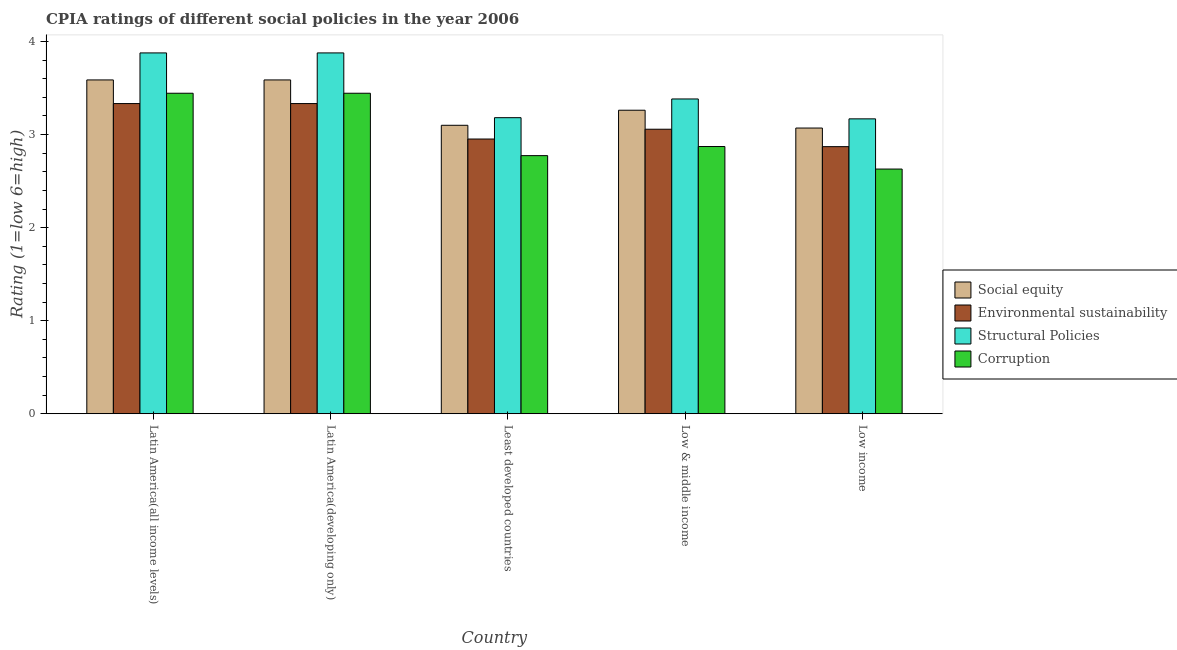How many different coloured bars are there?
Provide a succinct answer. 4. Are the number of bars on each tick of the X-axis equal?
Ensure brevity in your answer.  Yes. How many bars are there on the 1st tick from the left?
Make the answer very short. 4. What is the label of the 1st group of bars from the left?
Keep it short and to the point. Latin America(all income levels). What is the cpia rating of structural policies in Latin America(developing only)?
Your response must be concise. 3.88. Across all countries, what is the maximum cpia rating of corruption?
Make the answer very short. 3.44. Across all countries, what is the minimum cpia rating of social equity?
Provide a succinct answer. 3.07. In which country was the cpia rating of structural policies maximum?
Ensure brevity in your answer.  Latin America(all income levels). What is the total cpia rating of social equity in the graph?
Keep it short and to the point. 16.61. What is the difference between the cpia rating of social equity in Latin America(all income levels) and that in Least developed countries?
Provide a short and direct response. 0.49. What is the difference between the cpia rating of environmental sustainability in Latin America(developing only) and the cpia rating of social equity in Low & middle income?
Your answer should be compact. 0.07. What is the average cpia rating of social equity per country?
Make the answer very short. 3.32. What is the difference between the cpia rating of environmental sustainability and cpia rating of social equity in Least developed countries?
Provide a short and direct response. -0.15. In how many countries, is the cpia rating of structural policies greater than 1.2 ?
Provide a short and direct response. 5. What is the ratio of the cpia rating of corruption in Latin America(all income levels) to that in Least developed countries?
Offer a very short reply. 1.24. What is the difference between the highest and the second highest cpia rating of structural policies?
Your answer should be compact. 0. What is the difference between the highest and the lowest cpia rating of corruption?
Ensure brevity in your answer.  0.81. In how many countries, is the cpia rating of environmental sustainability greater than the average cpia rating of environmental sustainability taken over all countries?
Your response must be concise. 2. What does the 3rd bar from the left in Low income represents?
Keep it short and to the point. Structural Policies. What does the 3rd bar from the right in Latin America(developing only) represents?
Your answer should be compact. Environmental sustainability. How many bars are there?
Ensure brevity in your answer.  20. Are all the bars in the graph horizontal?
Ensure brevity in your answer.  No. What is the difference between two consecutive major ticks on the Y-axis?
Provide a short and direct response. 1. Are the values on the major ticks of Y-axis written in scientific E-notation?
Ensure brevity in your answer.  No. Does the graph contain any zero values?
Make the answer very short. No. Does the graph contain grids?
Offer a very short reply. No. How are the legend labels stacked?
Keep it short and to the point. Vertical. What is the title of the graph?
Your response must be concise. CPIA ratings of different social policies in the year 2006. What is the Rating (1=low 6=high) in Social equity in Latin America(all income levels)?
Provide a succinct answer. 3.59. What is the Rating (1=low 6=high) of Environmental sustainability in Latin America(all income levels)?
Keep it short and to the point. 3.33. What is the Rating (1=low 6=high) of Structural Policies in Latin America(all income levels)?
Your answer should be very brief. 3.88. What is the Rating (1=low 6=high) of Corruption in Latin America(all income levels)?
Give a very brief answer. 3.44. What is the Rating (1=low 6=high) in Social equity in Latin America(developing only)?
Keep it short and to the point. 3.59. What is the Rating (1=low 6=high) in Environmental sustainability in Latin America(developing only)?
Make the answer very short. 3.33. What is the Rating (1=low 6=high) in Structural Policies in Latin America(developing only)?
Your answer should be compact. 3.88. What is the Rating (1=low 6=high) of Corruption in Latin America(developing only)?
Provide a succinct answer. 3.44. What is the Rating (1=low 6=high) of Social equity in Least developed countries?
Your answer should be compact. 3.1. What is the Rating (1=low 6=high) of Environmental sustainability in Least developed countries?
Your answer should be compact. 2.95. What is the Rating (1=low 6=high) in Structural Policies in Least developed countries?
Your answer should be very brief. 3.18. What is the Rating (1=low 6=high) of Corruption in Least developed countries?
Your response must be concise. 2.77. What is the Rating (1=low 6=high) in Social equity in Low & middle income?
Ensure brevity in your answer.  3.26. What is the Rating (1=low 6=high) in Environmental sustainability in Low & middle income?
Your answer should be compact. 3.06. What is the Rating (1=low 6=high) of Structural Policies in Low & middle income?
Give a very brief answer. 3.38. What is the Rating (1=low 6=high) of Corruption in Low & middle income?
Your response must be concise. 2.87. What is the Rating (1=low 6=high) of Social equity in Low income?
Your answer should be compact. 3.07. What is the Rating (1=low 6=high) in Environmental sustainability in Low income?
Your answer should be compact. 2.87. What is the Rating (1=low 6=high) of Structural Policies in Low income?
Offer a very short reply. 3.17. What is the Rating (1=low 6=high) of Corruption in Low income?
Your response must be concise. 2.63. Across all countries, what is the maximum Rating (1=low 6=high) of Social equity?
Ensure brevity in your answer.  3.59. Across all countries, what is the maximum Rating (1=low 6=high) in Environmental sustainability?
Give a very brief answer. 3.33. Across all countries, what is the maximum Rating (1=low 6=high) of Structural Policies?
Give a very brief answer. 3.88. Across all countries, what is the maximum Rating (1=low 6=high) of Corruption?
Your answer should be compact. 3.44. Across all countries, what is the minimum Rating (1=low 6=high) of Social equity?
Offer a very short reply. 3.07. Across all countries, what is the minimum Rating (1=low 6=high) of Environmental sustainability?
Give a very brief answer. 2.87. Across all countries, what is the minimum Rating (1=low 6=high) in Structural Policies?
Offer a terse response. 3.17. Across all countries, what is the minimum Rating (1=low 6=high) in Corruption?
Your answer should be compact. 2.63. What is the total Rating (1=low 6=high) of Social equity in the graph?
Your answer should be very brief. 16.61. What is the total Rating (1=low 6=high) of Environmental sustainability in the graph?
Ensure brevity in your answer.  15.55. What is the total Rating (1=low 6=high) of Structural Policies in the graph?
Provide a short and direct response. 17.49. What is the total Rating (1=low 6=high) of Corruption in the graph?
Your response must be concise. 15.16. What is the difference between the Rating (1=low 6=high) in Social equity in Latin America(all income levels) and that in Latin America(developing only)?
Ensure brevity in your answer.  0. What is the difference between the Rating (1=low 6=high) of Environmental sustainability in Latin America(all income levels) and that in Latin America(developing only)?
Your answer should be compact. 0. What is the difference between the Rating (1=low 6=high) in Structural Policies in Latin America(all income levels) and that in Latin America(developing only)?
Give a very brief answer. 0. What is the difference between the Rating (1=low 6=high) in Corruption in Latin America(all income levels) and that in Latin America(developing only)?
Provide a succinct answer. 0. What is the difference between the Rating (1=low 6=high) of Social equity in Latin America(all income levels) and that in Least developed countries?
Your response must be concise. 0.49. What is the difference between the Rating (1=low 6=high) in Environmental sustainability in Latin America(all income levels) and that in Least developed countries?
Keep it short and to the point. 0.38. What is the difference between the Rating (1=low 6=high) in Structural Policies in Latin America(all income levels) and that in Least developed countries?
Provide a succinct answer. 0.7. What is the difference between the Rating (1=low 6=high) of Corruption in Latin America(all income levels) and that in Least developed countries?
Provide a succinct answer. 0.67. What is the difference between the Rating (1=low 6=high) in Social equity in Latin America(all income levels) and that in Low & middle income?
Offer a very short reply. 0.33. What is the difference between the Rating (1=low 6=high) of Environmental sustainability in Latin America(all income levels) and that in Low & middle income?
Give a very brief answer. 0.28. What is the difference between the Rating (1=low 6=high) of Structural Policies in Latin America(all income levels) and that in Low & middle income?
Provide a succinct answer. 0.49. What is the difference between the Rating (1=low 6=high) in Corruption in Latin America(all income levels) and that in Low & middle income?
Your answer should be very brief. 0.57. What is the difference between the Rating (1=low 6=high) of Social equity in Latin America(all income levels) and that in Low income?
Provide a short and direct response. 0.52. What is the difference between the Rating (1=low 6=high) in Environmental sustainability in Latin America(all income levels) and that in Low income?
Provide a succinct answer. 0.46. What is the difference between the Rating (1=low 6=high) of Structural Policies in Latin America(all income levels) and that in Low income?
Your answer should be compact. 0.71. What is the difference between the Rating (1=low 6=high) of Corruption in Latin America(all income levels) and that in Low income?
Keep it short and to the point. 0.81. What is the difference between the Rating (1=low 6=high) in Social equity in Latin America(developing only) and that in Least developed countries?
Your answer should be very brief. 0.49. What is the difference between the Rating (1=low 6=high) of Environmental sustainability in Latin America(developing only) and that in Least developed countries?
Make the answer very short. 0.38. What is the difference between the Rating (1=low 6=high) of Structural Policies in Latin America(developing only) and that in Least developed countries?
Your response must be concise. 0.7. What is the difference between the Rating (1=low 6=high) of Corruption in Latin America(developing only) and that in Least developed countries?
Keep it short and to the point. 0.67. What is the difference between the Rating (1=low 6=high) of Social equity in Latin America(developing only) and that in Low & middle income?
Your answer should be compact. 0.33. What is the difference between the Rating (1=low 6=high) of Environmental sustainability in Latin America(developing only) and that in Low & middle income?
Provide a short and direct response. 0.28. What is the difference between the Rating (1=low 6=high) of Structural Policies in Latin America(developing only) and that in Low & middle income?
Make the answer very short. 0.49. What is the difference between the Rating (1=low 6=high) in Corruption in Latin America(developing only) and that in Low & middle income?
Provide a short and direct response. 0.57. What is the difference between the Rating (1=low 6=high) in Social equity in Latin America(developing only) and that in Low income?
Provide a short and direct response. 0.52. What is the difference between the Rating (1=low 6=high) of Environmental sustainability in Latin America(developing only) and that in Low income?
Ensure brevity in your answer.  0.46. What is the difference between the Rating (1=low 6=high) of Structural Policies in Latin America(developing only) and that in Low income?
Offer a very short reply. 0.71. What is the difference between the Rating (1=low 6=high) in Corruption in Latin America(developing only) and that in Low income?
Your response must be concise. 0.81. What is the difference between the Rating (1=low 6=high) in Social equity in Least developed countries and that in Low & middle income?
Make the answer very short. -0.16. What is the difference between the Rating (1=low 6=high) of Environmental sustainability in Least developed countries and that in Low & middle income?
Your answer should be very brief. -0.11. What is the difference between the Rating (1=low 6=high) of Structural Policies in Least developed countries and that in Low & middle income?
Give a very brief answer. -0.2. What is the difference between the Rating (1=low 6=high) of Corruption in Least developed countries and that in Low & middle income?
Your response must be concise. -0.1. What is the difference between the Rating (1=low 6=high) in Social equity in Least developed countries and that in Low income?
Provide a short and direct response. 0.03. What is the difference between the Rating (1=low 6=high) in Environmental sustainability in Least developed countries and that in Low income?
Make the answer very short. 0.08. What is the difference between the Rating (1=low 6=high) in Structural Policies in Least developed countries and that in Low income?
Provide a succinct answer. 0.01. What is the difference between the Rating (1=low 6=high) of Corruption in Least developed countries and that in Low income?
Your response must be concise. 0.14. What is the difference between the Rating (1=low 6=high) of Social equity in Low & middle income and that in Low income?
Your answer should be compact. 0.19. What is the difference between the Rating (1=low 6=high) in Environmental sustainability in Low & middle income and that in Low income?
Your answer should be compact. 0.19. What is the difference between the Rating (1=low 6=high) of Structural Policies in Low & middle income and that in Low income?
Provide a succinct answer. 0.21. What is the difference between the Rating (1=low 6=high) of Corruption in Low & middle income and that in Low income?
Ensure brevity in your answer.  0.24. What is the difference between the Rating (1=low 6=high) of Social equity in Latin America(all income levels) and the Rating (1=low 6=high) of Environmental sustainability in Latin America(developing only)?
Make the answer very short. 0.25. What is the difference between the Rating (1=low 6=high) in Social equity in Latin America(all income levels) and the Rating (1=low 6=high) in Structural Policies in Latin America(developing only)?
Provide a succinct answer. -0.29. What is the difference between the Rating (1=low 6=high) in Social equity in Latin America(all income levels) and the Rating (1=low 6=high) in Corruption in Latin America(developing only)?
Make the answer very short. 0.14. What is the difference between the Rating (1=low 6=high) of Environmental sustainability in Latin America(all income levels) and the Rating (1=low 6=high) of Structural Policies in Latin America(developing only)?
Your answer should be very brief. -0.54. What is the difference between the Rating (1=low 6=high) of Environmental sustainability in Latin America(all income levels) and the Rating (1=low 6=high) of Corruption in Latin America(developing only)?
Your response must be concise. -0.11. What is the difference between the Rating (1=low 6=high) of Structural Policies in Latin America(all income levels) and the Rating (1=low 6=high) of Corruption in Latin America(developing only)?
Ensure brevity in your answer.  0.43. What is the difference between the Rating (1=low 6=high) of Social equity in Latin America(all income levels) and the Rating (1=low 6=high) of Environmental sustainability in Least developed countries?
Give a very brief answer. 0.64. What is the difference between the Rating (1=low 6=high) in Social equity in Latin America(all income levels) and the Rating (1=low 6=high) in Structural Policies in Least developed countries?
Offer a terse response. 0.41. What is the difference between the Rating (1=low 6=high) in Social equity in Latin America(all income levels) and the Rating (1=low 6=high) in Corruption in Least developed countries?
Ensure brevity in your answer.  0.81. What is the difference between the Rating (1=low 6=high) of Environmental sustainability in Latin America(all income levels) and the Rating (1=low 6=high) of Structural Policies in Least developed countries?
Ensure brevity in your answer.  0.15. What is the difference between the Rating (1=low 6=high) in Environmental sustainability in Latin America(all income levels) and the Rating (1=low 6=high) in Corruption in Least developed countries?
Provide a short and direct response. 0.56. What is the difference between the Rating (1=low 6=high) of Structural Policies in Latin America(all income levels) and the Rating (1=low 6=high) of Corruption in Least developed countries?
Your answer should be compact. 1.1. What is the difference between the Rating (1=low 6=high) of Social equity in Latin America(all income levels) and the Rating (1=low 6=high) of Environmental sustainability in Low & middle income?
Your response must be concise. 0.53. What is the difference between the Rating (1=low 6=high) in Social equity in Latin America(all income levels) and the Rating (1=low 6=high) in Structural Policies in Low & middle income?
Give a very brief answer. 0.2. What is the difference between the Rating (1=low 6=high) in Social equity in Latin America(all income levels) and the Rating (1=low 6=high) in Corruption in Low & middle income?
Offer a terse response. 0.72. What is the difference between the Rating (1=low 6=high) of Environmental sustainability in Latin America(all income levels) and the Rating (1=low 6=high) of Structural Policies in Low & middle income?
Offer a terse response. -0.05. What is the difference between the Rating (1=low 6=high) in Environmental sustainability in Latin America(all income levels) and the Rating (1=low 6=high) in Corruption in Low & middle income?
Offer a very short reply. 0.46. What is the difference between the Rating (1=low 6=high) of Structural Policies in Latin America(all income levels) and the Rating (1=low 6=high) of Corruption in Low & middle income?
Give a very brief answer. 1.01. What is the difference between the Rating (1=low 6=high) in Social equity in Latin America(all income levels) and the Rating (1=low 6=high) in Environmental sustainability in Low income?
Give a very brief answer. 0.72. What is the difference between the Rating (1=low 6=high) in Social equity in Latin America(all income levels) and the Rating (1=low 6=high) in Structural Policies in Low income?
Your answer should be very brief. 0.42. What is the difference between the Rating (1=low 6=high) in Social equity in Latin America(all income levels) and the Rating (1=low 6=high) in Corruption in Low income?
Offer a very short reply. 0.96. What is the difference between the Rating (1=low 6=high) in Environmental sustainability in Latin America(all income levels) and the Rating (1=low 6=high) in Structural Policies in Low income?
Offer a very short reply. 0.16. What is the difference between the Rating (1=low 6=high) in Environmental sustainability in Latin America(all income levels) and the Rating (1=low 6=high) in Corruption in Low income?
Your answer should be compact. 0.7. What is the difference between the Rating (1=low 6=high) of Structural Policies in Latin America(all income levels) and the Rating (1=low 6=high) of Corruption in Low income?
Offer a terse response. 1.25. What is the difference between the Rating (1=low 6=high) of Social equity in Latin America(developing only) and the Rating (1=low 6=high) of Environmental sustainability in Least developed countries?
Your response must be concise. 0.64. What is the difference between the Rating (1=low 6=high) in Social equity in Latin America(developing only) and the Rating (1=low 6=high) in Structural Policies in Least developed countries?
Make the answer very short. 0.41. What is the difference between the Rating (1=low 6=high) in Social equity in Latin America(developing only) and the Rating (1=low 6=high) in Corruption in Least developed countries?
Offer a terse response. 0.81. What is the difference between the Rating (1=low 6=high) of Environmental sustainability in Latin America(developing only) and the Rating (1=low 6=high) of Structural Policies in Least developed countries?
Your response must be concise. 0.15. What is the difference between the Rating (1=low 6=high) of Environmental sustainability in Latin America(developing only) and the Rating (1=low 6=high) of Corruption in Least developed countries?
Make the answer very short. 0.56. What is the difference between the Rating (1=low 6=high) in Structural Policies in Latin America(developing only) and the Rating (1=low 6=high) in Corruption in Least developed countries?
Keep it short and to the point. 1.1. What is the difference between the Rating (1=low 6=high) in Social equity in Latin America(developing only) and the Rating (1=low 6=high) in Environmental sustainability in Low & middle income?
Offer a very short reply. 0.53. What is the difference between the Rating (1=low 6=high) in Social equity in Latin America(developing only) and the Rating (1=low 6=high) in Structural Policies in Low & middle income?
Offer a terse response. 0.2. What is the difference between the Rating (1=low 6=high) in Social equity in Latin America(developing only) and the Rating (1=low 6=high) in Corruption in Low & middle income?
Your answer should be very brief. 0.72. What is the difference between the Rating (1=low 6=high) of Environmental sustainability in Latin America(developing only) and the Rating (1=low 6=high) of Structural Policies in Low & middle income?
Offer a terse response. -0.05. What is the difference between the Rating (1=low 6=high) in Environmental sustainability in Latin America(developing only) and the Rating (1=low 6=high) in Corruption in Low & middle income?
Offer a very short reply. 0.46. What is the difference between the Rating (1=low 6=high) in Social equity in Latin America(developing only) and the Rating (1=low 6=high) in Environmental sustainability in Low income?
Keep it short and to the point. 0.72. What is the difference between the Rating (1=low 6=high) in Social equity in Latin America(developing only) and the Rating (1=low 6=high) in Structural Policies in Low income?
Your answer should be compact. 0.42. What is the difference between the Rating (1=low 6=high) in Social equity in Latin America(developing only) and the Rating (1=low 6=high) in Corruption in Low income?
Keep it short and to the point. 0.96. What is the difference between the Rating (1=low 6=high) of Environmental sustainability in Latin America(developing only) and the Rating (1=low 6=high) of Structural Policies in Low income?
Make the answer very short. 0.16. What is the difference between the Rating (1=low 6=high) of Environmental sustainability in Latin America(developing only) and the Rating (1=low 6=high) of Corruption in Low income?
Offer a terse response. 0.7. What is the difference between the Rating (1=low 6=high) in Structural Policies in Latin America(developing only) and the Rating (1=low 6=high) in Corruption in Low income?
Offer a very short reply. 1.25. What is the difference between the Rating (1=low 6=high) in Social equity in Least developed countries and the Rating (1=low 6=high) in Environmental sustainability in Low & middle income?
Give a very brief answer. 0.04. What is the difference between the Rating (1=low 6=high) in Social equity in Least developed countries and the Rating (1=low 6=high) in Structural Policies in Low & middle income?
Your answer should be very brief. -0.28. What is the difference between the Rating (1=low 6=high) in Social equity in Least developed countries and the Rating (1=low 6=high) in Corruption in Low & middle income?
Your answer should be compact. 0.23. What is the difference between the Rating (1=low 6=high) in Environmental sustainability in Least developed countries and the Rating (1=low 6=high) in Structural Policies in Low & middle income?
Provide a short and direct response. -0.43. What is the difference between the Rating (1=low 6=high) in Environmental sustainability in Least developed countries and the Rating (1=low 6=high) in Corruption in Low & middle income?
Your answer should be very brief. 0.08. What is the difference between the Rating (1=low 6=high) of Structural Policies in Least developed countries and the Rating (1=low 6=high) of Corruption in Low & middle income?
Your answer should be compact. 0.31. What is the difference between the Rating (1=low 6=high) in Social equity in Least developed countries and the Rating (1=low 6=high) in Environmental sustainability in Low income?
Your response must be concise. 0.23. What is the difference between the Rating (1=low 6=high) in Social equity in Least developed countries and the Rating (1=low 6=high) in Structural Policies in Low income?
Your answer should be very brief. -0.07. What is the difference between the Rating (1=low 6=high) in Social equity in Least developed countries and the Rating (1=low 6=high) in Corruption in Low income?
Ensure brevity in your answer.  0.47. What is the difference between the Rating (1=low 6=high) of Environmental sustainability in Least developed countries and the Rating (1=low 6=high) of Structural Policies in Low income?
Your answer should be compact. -0.22. What is the difference between the Rating (1=low 6=high) of Environmental sustainability in Least developed countries and the Rating (1=low 6=high) of Corruption in Low income?
Provide a succinct answer. 0.32. What is the difference between the Rating (1=low 6=high) in Structural Policies in Least developed countries and the Rating (1=low 6=high) in Corruption in Low income?
Make the answer very short. 0.55. What is the difference between the Rating (1=low 6=high) in Social equity in Low & middle income and the Rating (1=low 6=high) in Environmental sustainability in Low income?
Offer a terse response. 0.39. What is the difference between the Rating (1=low 6=high) in Social equity in Low & middle income and the Rating (1=low 6=high) in Structural Policies in Low income?
Keep it short and to the point. 0.09. What is the difference between the Rating (1=low 6=high) of Social equity in Low & middle income and the Rating (1=low 6=high) of Corruption in Low income?
Ensure brevity in your answer.  0.63. What is the difference between the Rating (1=low 6=high) of Environmental sustainability in Low & middle income and the Rating (1=low 6=high) of Structural Policies in Low income?
Give a very brief answer. -0.11. What is the difference between the Rating (1=low 6=high) in Environmental sustainability in Low & middle income and the Rating (1=low 6=high) in Corruption in Low income?
Provide a succinct answer. 0.43. What is the difference between the Rating (1=low 6=high) of Structural Policies in Low & middle income and the Rating (1=low 6=high) of Corruption in Low income?
Give a very brief answer. 0.75. What is the average Rating (1=low 6=high) of Social equity per country?
Offer a terse response. 3.32. What is the average Rating (1=low 6=high) in Environmental sustainability per country?
Make the answer very short. 3.11. What is the average Rating (1=low 6=high) of Structural Policies per country?
Provide a succinct answer. 3.5. What is the average Rating (1=low 6=high) of Corruption per country?
Provide a short and direct response. 3.03. What is the difference between the Rating (1=low 6=high) in Social equity and Rating (1=low 6=high) in Environmental sustainability in Latin America(all income levels)?
Keep it short and to the point. 0.25. What is the difference between the Rating (1=low 6=high) in Social equity and Rating (1=low 6=high) in Structural Policies in Latin America(all income levels)?
Offer a very short reply. -0.29. What is the difference between the Rating (1=low 6=high) of Social equity and Rating (1=low 6=high) of Corruption in Latin America(all income levels)?
Provide a short and direct response. 0.14. What is the difference between the Rating (1=low 6=high) of Environmental sustainability and Rating (1=low 6=high) of Structural Policies in Latin America(all income levels)?
Provide a succinct answer. -0.54. What is the difference between the Rating (1=low 6=high) in Environmental sustainability and Rating (1=low 6=high) in Corruption in Latin America(all income levels)?
Provide a succinct answer. -0.11. What is the difference between the Rating (1=low 6=high) in Structural Policies and Rating (1=low 6=high) in Corruption in Latin America(all income levels)?
Provide a short and direct response. 0.43. What is the difference between the Rating (1=low 6=high) of Social equity and Rating (1=low 6=high) of Environmental sustainability in Latin America(developing only)?
Give a very brief answer. 0.25. What is the difference between the Rating (1=low 6=high) in Social equity and Rating (1=low 6=high) in Structural Policies in Latin America(developing only)?
Offer a terse response. -0.29. What is the difference between the Rating (1=low 6=high) of Social equity and Rating (1=low 6=high) of Corruption in Latin America(developing only)?
Your answer should be very brief. 0.14. What is the difference between the Rating (1=low 6=high) of Environmental sustainability and Rating (1=low 6=high) of Structural Policies in Latin America(developing only)?
Make the answer very short. -0.54. What is the difference between the Rating (1=low 6=high) in Environmental sustainability and Rating (1=low 6=high) in Corruption in Latin America(developing only)?
Give a very brief answer. -0.11. What is the difference between the Rating (1=low 6=high) in Structural Policies and Rating (1=low 6=high) in Corruption in Latin America(developing only)?
Ensure brevity in your answer.  0.43. What is the difference between the Rating (1=low 6=high) of Social equity and Rating (1=low 6=high) of Environmental sustainability in Least developed countries?
Offer a terse response. 0.15. What is the difference between the Rating (1=low 6=high) of Social equity and Rating (1=low 6=high) of Structural Policies in Least developed countries?
Your response must be concise. -0.08. What is the difference between the Rating (1=low 6=high) in Social equity and Rating (1=low 6=high) in Corruption in Least developed countries?
Provide a short and direct response. 0.33. What is the difference between the Rating (1=low 6=high) in Environmental sustainability and Rating (1=low 6=high) in Structural Policies in Least developed countries?
Make the answer very short. -0.23. What is the difference between the Rating (1=low 6=high) of Environmental sustainability and Rating (1=low 6=high) of Corruption in Least developed countries?
Ensure brevity in your answer.  0.18. What is the difference between the Rating (1=low 6=high) of Structural Policies and Rating (1=low 6=high) of Corruption in Least developed countries?
Make the answer very short. 0.41. What is the difference between the Rating (1=low 6=high) in Social equity and Rating (1=low 6=high) in Environmental sustainability in Low & middle income?
Provide a short and direct response. 0.2. What is the difference between the Rating (1=low 6=high) of Social equity and Rating (1=low 6=high) of Structural Policies in Low & middle income?
Your response must be concise. -0.12. What is the difference between the Rating (1=low 6=high) in Social equity and Rating (1=low 6=high) in Corruption in Low & middle income?
Ensure brevity in your answer.  0.39. What is the difference between the Rating (1=low 6=high) in Environmental sustainability and Rating (1=low 6=high) in Structural Policies in Low & middle income?
Your answer should be very brief. -0.33. What is the difference between the Rating (1=low 6=high) of Environmental sustainability and Rating (1=low 6=high) of Corruption in Low & middle income?
Ensure brevity in your answer.  0.19. What is the difference between the Rating (1=low 6=high) of Structural Policies and Rating (1=low 6=high) of Corruption in Low & middle income?
Make the answer very short. 0.51. What is the difference between the Rating (1=low 6=high) in Social equity and Rating (1=low 6=high) in Environmental sustainability in Low income?
Your response must be concise. 0.2. What is the difference between the Rating (1=low 6=high) in Social equity and Rating (1=low 6=high) in Structural Policies in Low income?
Your response must be concise. -0.1. What is the difference between the Rating (1=low 6=high) in Social equity and Rating (1=low 6=high) in Corruption in Low income?
Give a very brief answer. 0.44. What is the difference between the Rating (1=low 6=high) in Environmental sustainability and Rating (1=low 6=high) in Structural Policies in Low income?
Offer a very short reply. -0.3. What is the difference between the Rating (1=low 6=high) of Environmental sustainability and Rating (1=low 6=high) of Corruption in Low income?
Make the answer very short. 0.24. What is the difference between the Rating (1=low 6=high) in Structural Policies and Rating (1=low 6=high) in Corruption in Low income?
Your response must be concise. 0.54. What is the ratio of the Rating (1=low 6=high) of Structural Policies in Latin America(all income levels) to that in Latin America(developing only)?
Offer a terse response. 1. What is the ratio of the Rating (1=low 6=high) in Corruption in Latin America(all income levels) to that in Latin America(developing only)?
Your answer should be compact. 1. What is the ratio of the Rating (1=low 6=high) in Social equity in Latin America(all income levels) to that in Least developed countries?
Offer a terse response. 1.16. What is the ratio of the Rating (1=low 6=high) in Environmental sustainability in Latin America(all income levels) to that in Least developed countries?
Keep it short and to the point. 1.13. What is the ratio of the Rating (1=low 6=high) of Structural Policies in Latin America(all income levels) to that in Least developed countries?
Ensure brevity in your answer.  1.22. What is the ratio of the Rating (1=low 6=high) in Corruption in Latin America(all income levels) to that in Least developed countries?
Your answer should be very brief. 1.24. What is the ratio of the Rating (1=low 6=high) of Social equity in Latin America(all income levels) to that in Low & middle income?
Ensure brevity in your answer.  1.1. What is the ratio of the Rating (1=low 6=high) in Environmental sustainability in Latin America(all income levels) to that in Low & middle income?
Provide a succinct answer. 1.09. What is the ratio of the Rating (1=low 6=high) of Structural Policies in Latin America(all income levels) to that in Low & middle income?
Offer a very short reply. 1.15. What is the ratio of the Rating (1=low 6=high) of Corruption in Latin America(all income levels) to that in Low & middle income?
Provide a short and direct response. 1.2. What is the ratio of the Rating (1=low 6=high) in Social equity in Latin America(all income levels) to that in Low income?
Ensure brevity in your answer.  1.17. What is the ratio of the Rating (1=low 6=high) in Environmental sustainability in Latin America(all income levels) to that in Low income?
Provide a succinct answer. 1.16. What is the ratio of the Rating (1=low 6=high) of Structural Policies in Latin America(all income levels) to that in Low income?
Your response must be concise. 1.22. What is the ratio of the Rating (1=low 6=high) in Corruption in Latin America(all income levels) to that in Low income?
Your response must be concise. 1.31. What is the ratio of the Rating (1=low 6=high) of Social equity in Latin America(developing only) to that in Least developed countries?
Your answer should be very brief. 1.16. What is the ratio of the Rating (1=low 6=high) of Environmental sustainability in Latin America(developing only) to that in Least developed countries?
Offer a very short reply. 1.13. What is the ratio of the Rating (1=low 6=high) in Structural Policies in Latin America(developing only) to that in Least developed countries?
Provide a succinct answer. 1.22. What is the ratio of the Rating (1=low 6=high) in Corruption in Latin America(developing only) to that in Least developed countries?
Your answer should be very brief. 1.24. What is the ratio of the Rating (1=low 6=high) in Social equity in Latin America(developing only) to that in Low & middle income?
Give a very brief answer. 1.1. What is the ratio of the Rating (1=low 6=high) in Environmental sustainability in Latin America(developing only) to that in Low & middle income?
Your response must be concise. 1.09. What is the ratio of the Rating (1=low 6=high) of Structural Policies in Latin America(developing only) to that in Low & middle income?
Offer a terse response. 1.15. What is the ratio of the Rating (1=low 6=high) of Corruption in Latin America(developing only) to that in Low & middle income?
Ensure brevity in your answer.  1.2. What is the ratio of the Rating (1=low 6=high) of Social equity in Latin America(developing only) to that in Low income?
Provide a short and direct response. 1.17. What is the ratio of the Rating (1=low 6=high) of Environmental sustainability in Latin America(developing only) to that in Low income?
Provide a short and direct response. 1.16. What is the ratio of the Rating (1=low 6=high) in Structural Policies in Latin America(developing only) to that in Low income?
Provide a short and direct response. 1.22. What is the ratio of the Rating (1=low 6=high) of Corruption in Latin America(developing only) to that in Low income?
Provide a succinct answer. 1.31. What is the ratio of the Rating (1=low 6=high) of Social equity in Least developed countries to that in Low & middle income?
Make the answer very short. 0.95. What is the ratio of the Rating (1=low 6=high) in Environmental sustainability in Least developed countries to that in Low & middle income?
Your answer should be very brief. 0.97. What is the ratio of the Rating (1=low 6=high) of Structural Policies in Least developed countries to that in Low & middle income?
Make the answer very short. 0.94. What is the ratio of the Rating (1=low 6=high) in Corruption in Least developed countries to that in Low & middle income?
Provide a short and direct response. 0.97. What is the ratio of the Rating (1=low 6=high) in Social equity in Least developed countries to that in Low income?
Provide a short and direct response. 1.01. What is the ratio of the Rating (1=low 6=high) of Environmental sustainability in Least developed countries to that in Low income?
Provide a short and direct response. 1.03. What is the ratio of the Rating (1=low 6=high) in Structural Policies in Least developed countries to that in Low income?
Provide a short and direct response. 1. What is the ratio of the Rating (1=low 6=high) of Corruption in Least developed countries to that in Low income?
Provide a short and direct response. 1.05. What is the ratio of the Rating (1=low 6=high) in Social equity in Low & middle income to that in Low income?
Ensure brevity in your answer.  1.06. What is the ratio of the Rating (1=low 6=high) of Environmental sustainability in Low & middle income to that in Low income?
Provide a succinct answer. 1.07. What is the ratio of the Rating (1=low 6=high) of Structural Policies in Low & middle income to that in Low income?
Provide a short and direct response. 1.07. What is the ratio of the Rating (1=low 6=high) in Corruption in Low & middle income to that in Low income?
Make the answer very short. 1.09. What is the difference between the highest and the second highest Rating (1=low 6=high) in Social equity?
Ensure brevity in your answer.  0. What is the difference between the highest and the second highest Rating (1=low 6=high) in Environmental sustainability?
Provide a succinct answer. 0. What is the difference between the highest and the lowest Rating (1=low 6=high) in Social equity?
Ensure brevity in your answer.  0.52. What is the difference between the highest and the lowest Rating (1=low 6=high) in Environmental sustainability?
Your response must be concise. 0.46. What is the difference between the highest and the lowest Rating (1=low 6=high) of Structural Policies?
Give a very brief answer. 0.71. What is the difference between the highest and the lowest Rating (1=low 6=high) of Corruption?
Your answer should be very brief. 0.81. 